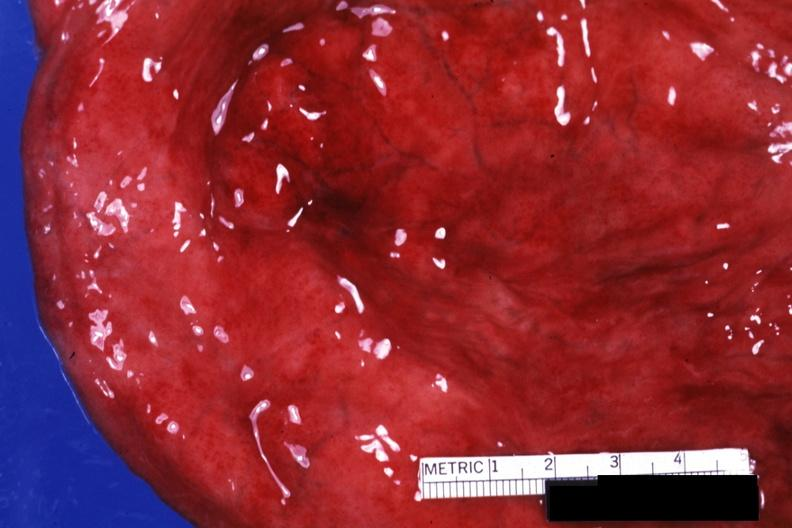where is this?
Answer the question using a single word or phrase. Urinary 